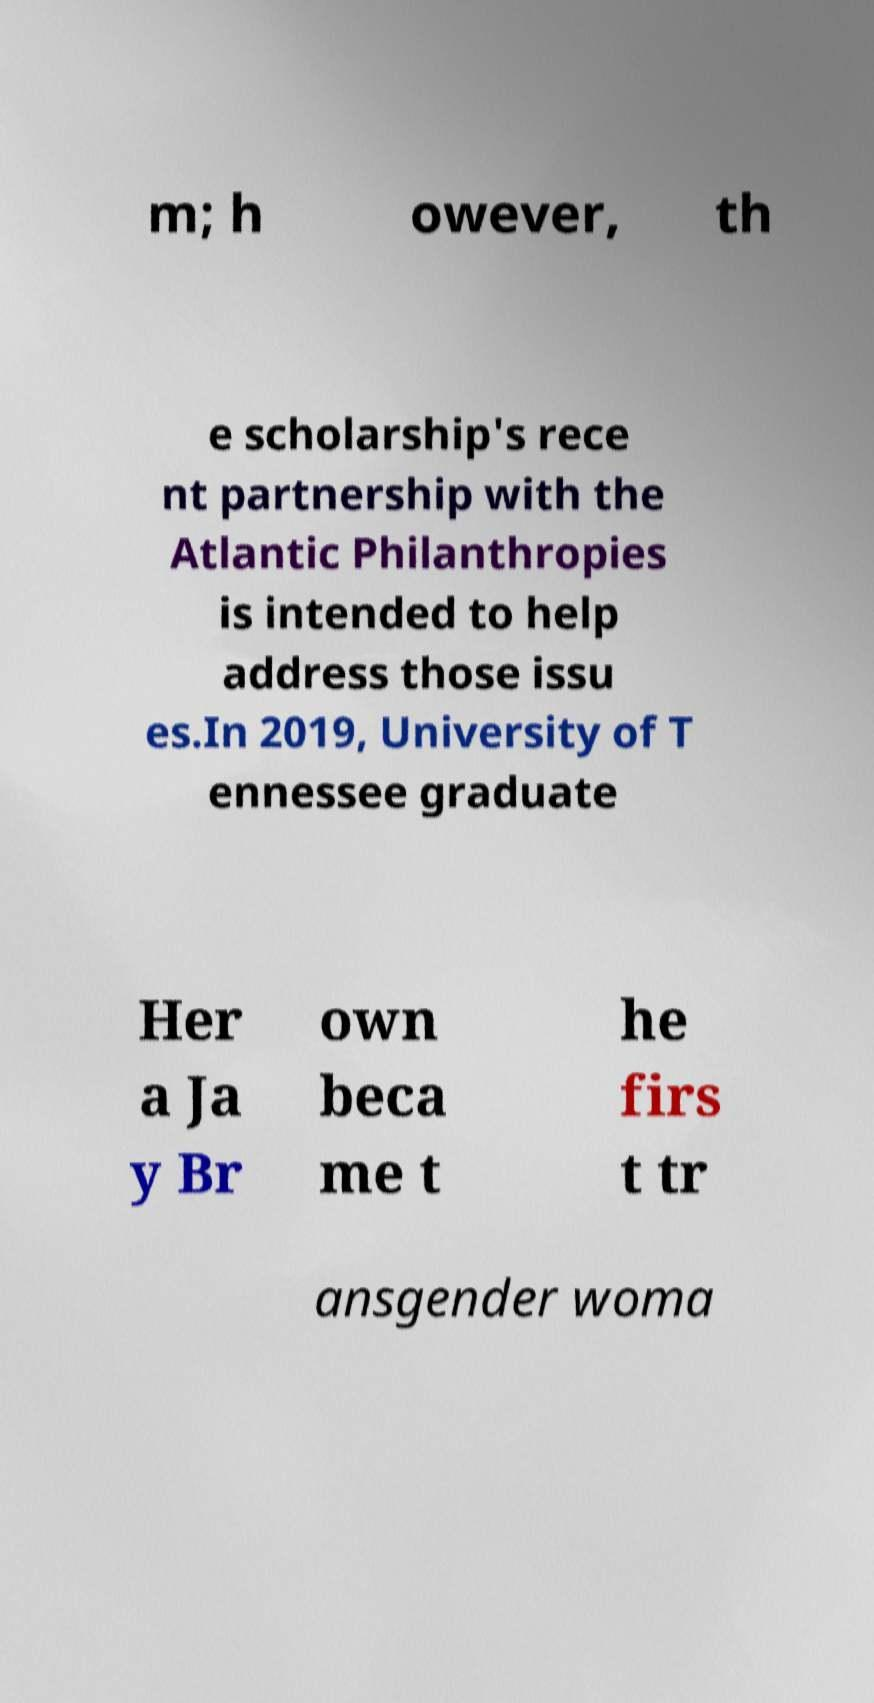There's text embedded in this image that I need extracted. Can you transcribe it verbatim? m; h owever, th e scholarship's rece nt partnership with the Atlantic Philanthropies is intended to help address those issu es.In 2019, University of T ennessee graduate Her a Ja y Br own beca me t he firs t tr ansgender woma 